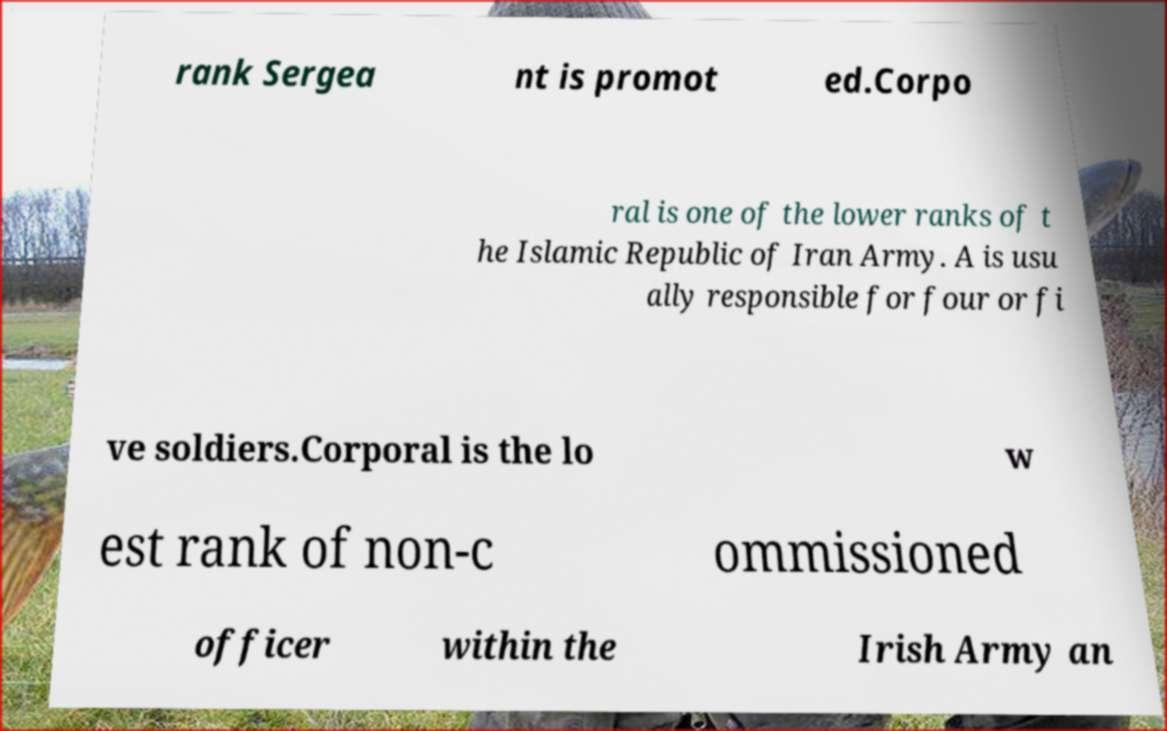Can you accurately transcribe the text from the provided image for me? rank Sergea nt is promot ed.Corpo ral is one of the lower ranks of t he Islamic Republic of Iran Army. A is usu ally responsible for four or fi ve soldiers.Corporal is the lo w est rank of non-c ommissioned officer within the Irish Army an 